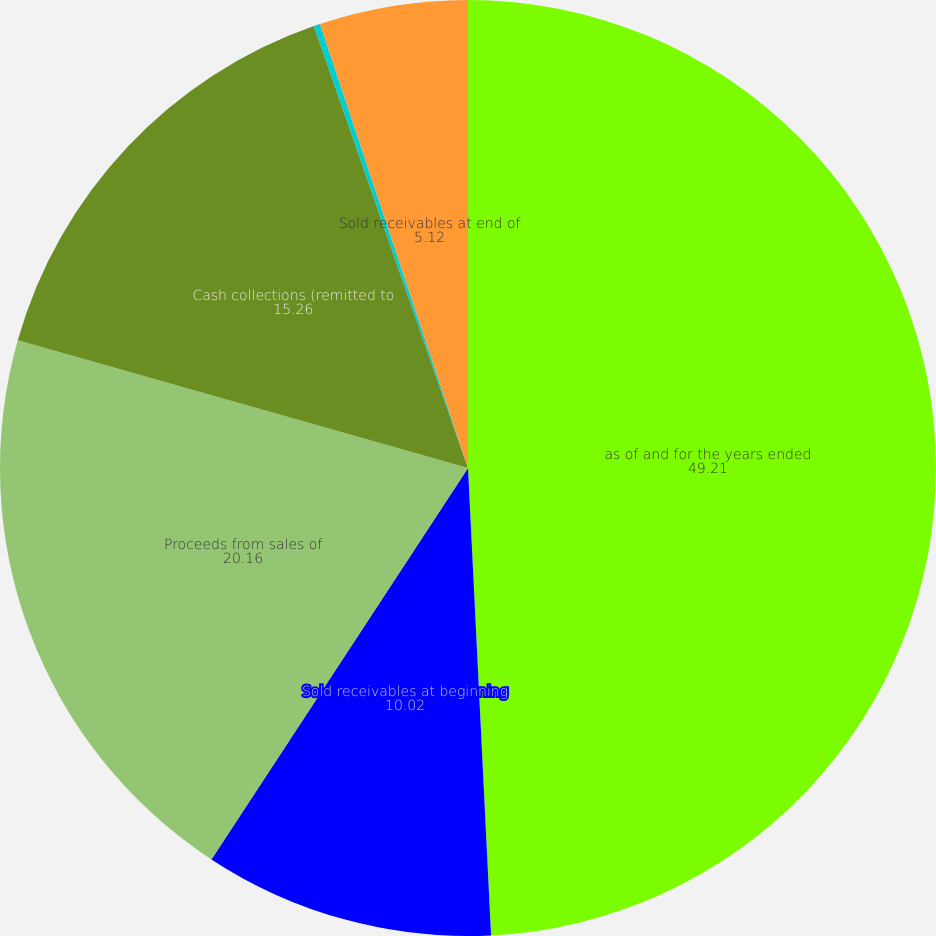Convert chart to OTSL. <chart><loc_0><loc_0><loc_500><loc_500><pie_chart><fcel>as of and for the years ended<fcel>Sold receivables at beginning<fcel>Proceeds from sales of<fcel>Cash collections (remitted to<fcel>Effect of currency exchange<fcel>Sold receivables at end of<nl><fcel>49.21%<fcel>10.02%<fcel>20.16%<fcel>15.26%<fcel>0.22%<fcel>5.12%<nl></chart> 